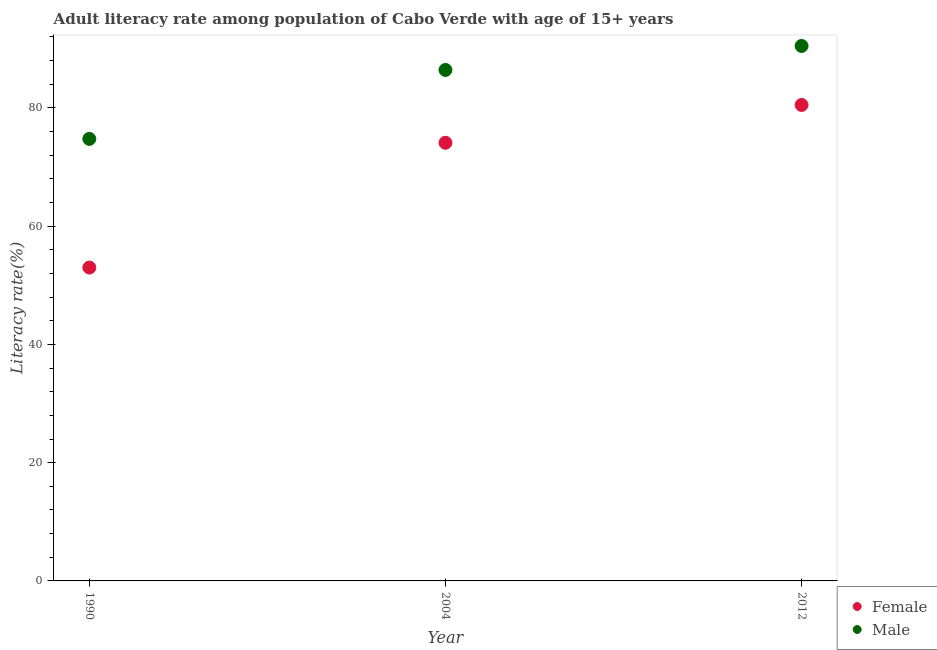What is the male adult literacy rate in 1990?
Offer a terse response. 74.76. Across all years, what is the maximum male adult literacy rate?
Your answer should be very brief. 90.47. Across all years, what is the minimum female adult literacy rate?
Provide a succinct answer. 53. In which year was the female adult literacy rate minimum?
Give a very brief answer. 1990. What is the total male adult literacy rate in the graph?
Your answer should be compact. 251.65. What is the difference between the female adult literacy rate in 2004 and that in 2012?
Keep it short and to the point. -6.4. What is the difference between the female adult literacy rate in 1990 and the male adult literacy rate in 2004?
Offer a very short reply. -33.42. What is the average female adult literacy rate per year?
Keep it short and to the point. 69.2. In the year 1990, what is the difference between the male adult literacy rate and female adult literacy rate?
Give a very brief answer. 21.76. What is the ratio of the male adult literacy rate in 1990 to that in 2004?
Provide a short and direct response. 0.87. Is the male adult literacy rate in 1990 less than that in 2012?
Ensure brevity in your answer.  Yes. What is the difference between the highest and the second highest female adult literacy rate?
Offer a very short reply. 6.4. What is the difference between the highest and the lowest female adult literacy rate?
Your response must be concise. 27.5. Does the female adult literacy rate monotonically increase over the years?
Offer a very short reply. Yes. Is the female adult literacy rate strictly greater than the male adult literacy rate over the years?
Your response must be concise. No. How many dotlines are there?
Keep it short and to the point. 2. How many years are there in the graph?
Give a very brief answer. 3. What is the difference between two consecutive major ticks on the Y-axis?
Offer a terse response. 20. Does the graph contain any zero values?
Ensure brevity in your answer.  No. How are the legend labels stacked?
Your response must be concise. Vertical. What is the title of the graph?
Your answer should be very brief. Adult literacy rate among population of Cabo Verde with age of 15+ years. Does "International Visitors" appear as one of the legend labels in the graph?
Your answer should be very brief. No. What is the label or title of the Y-axis?
Your answer should be compact. Literacy rate(%). What is the Literacy rate(%) of Female in 1990?
Keep it short and to the point. 53. What is the Literacy rate(%) of Male in 1990?
Your response must be concise. 74.76. What is the Literacy rate(%) in Female in 2004?
Keep it short and to the point. 74.1. What is the Literacy rate(%) of Male in 2004?
Provide a succinct answer. 86.41. What is the Literacy rate(%) in Female in 2012?
Offer a terse response. 80.5. What is the Literacy rate(%) of Male in 2012?
Your answer should be compact. 90.47. Across all years, what is the maximum Literacy rate(%) of Female?
Offer a terse response. 80.5. Across all years, what is the maximum Literacy rate(%) of Male?
Make the answer very short. 90.47. Across all years, what is the minimum Literacy rate(%) in Female?
Your response must be concise. 53. Across all years, what is the minimum Literacy rate(%) of Male?
Provide a succinct answer. 74.76. What is the total Literacy rate(%) in Female in the graph?
Offer a very short reply. 207.6. What is the total Literacy rate(%) in Male in the graph?
Make the answer very short. 251.65. What is the difference between the Literacy rate(%) in Female in 1990 and that in 2004?
Keep it short and to the point. -21.1. What is the difference between the Literacy rate(%) in Male in 1990 and that in 2004?
Your answer should be compact. -11.66. What is the difference between the Literacy rate(%) in Female in 1990 and that in 2012?
Your response must be concise. -27.5. What is the difference between the Literacy rate(%) in Male in 1990 and that in 2012?
Offer a very short reply. -15.72. What is the difference between the Literacy rate(%) in Female in 2004 and that in 2012?
Your answer should be compact. -6.4. What is the difference between the Literacy rate(%) of Male in 2004 and that in 2012?
Keep it short and to the point. -4.06. What is the difference between the Literacy rate(%) in Female in 1990 and the Literacy rate(%) in Male in 2004?
Keep it short and to the point. -33.42. What is the difference between the Literacy rate(%) of Female in 1990 and the Literacy rate(%) of Male in 2012?
Provide a short and direct response. -37.48. What is the difference between the Literacy rate(%) of Female in 2004 and the Literacy rate(%) of Male in 2012?
Ensure brevity in your answer.  -16.37. What is the average Literacy rate(%) of Female per year?
Offer a very short reply. 69.2. What is the average Literacy rate(%) of Male per year?
Offer a terse response. 83.88. In the year 1990, what is the difference between the Literacy rate(%) of Female and Literacy rate(%) of Male?
Your answer should be very brief. -21.76. In the year 2004, what is the difference between the Literacy rate(%) of Female and Literacy rate(%) of Male?
Your answer should be very brief. -12.31. In the year 2012, what is the difference between the Literacy rate(%) of Female and Literacy rate(%) of Male?
Ensure brevity in your answer.  -9.98. What is the ratio of the Literacy rate(%) in Female in 1990 to that in 2004?
Keep it short and to the point. 0.72. What is the ratio of the Literacy rate(%) of Male in 1990 to that in 2004?
Make the answer very short. 0.87. What is the ratio of the Literacy rate(%) of Female in 1990 to that in 2012?
Provide a succinct answer. 0.66. What is the ratio of the Literacy rate(%) in Male in 1990 to that in 2012?
Provide a succinct answer. 0.83. What is the ratio of the Literacy rate(%) in Female in 2004 to that in 2012?
Offer a terse response. 0.92. What is the ratio of the Literacy rate(%) in Male in 2004 to that in 2012?
Ensure brevity in your answer.  0.96. What is the difference between the highest and the second highest Literacy rate(%) in Female?
Make the answer very short. 6.4. What is the difference between the highest and the second highest Literacy rate(%) of Male?
Offer a terse response. 4.06. What is the difference between the highest and the lowest Literacy rate(%) in Female?
Give a very brief answer. 27.5. What is the difference between the highest and the lowest Literacy rate(%) of Male?
Give a very brief answer. 15.72. 